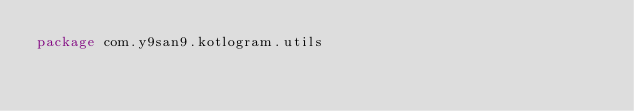<code> <loc_0><loc_0><loc_500><loc_500><_Kotlin_>package com.y9san9.kotlogram.utils
</code> 